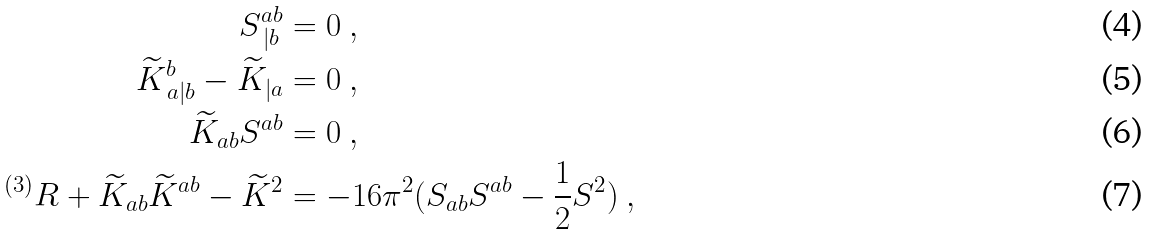Convert formula to latex. <formula><loc_0><loc_0><loc_500><loc_500>S ^ { a b } _ { \, | b } & = 0 \ , \\ \widetilde { K } ^ { b } _ { \, a | b } - \widetilde { K } _ { | a } & = 0 \ , \\ \widetilde { K } _ { a b } S ^ { a b } & = 0 \ , \\ ^ { ( 3 ) } R + \widetilde { K } _ { a b } \widetilde { K } ^ { a b } - \widetilde { K } ^ { 2 } & = - 1 6 \pi ^ { 2 } ( S _ { a b } S ^ { a b } - \frac { 1 } { 2 } S ^ { 2 } ) \ ,</formula> 